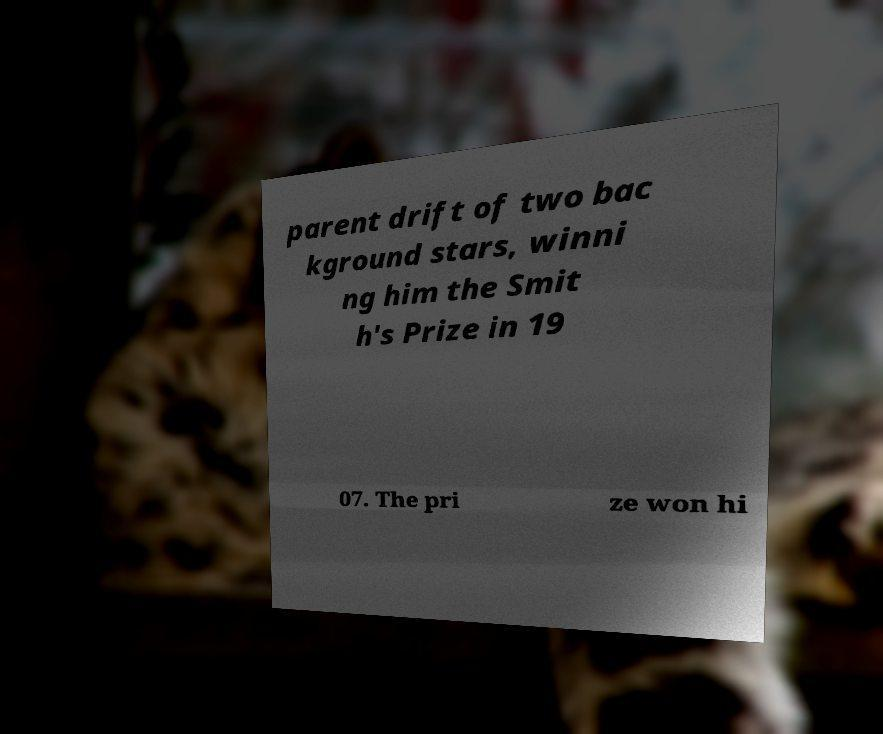There's text embedded in this image that I need extracted. Can you transcribe it verbatim? parent drift of two bac kground stars, winni ng him the Smit h's Prize in 19 07. The pri ze won hi 